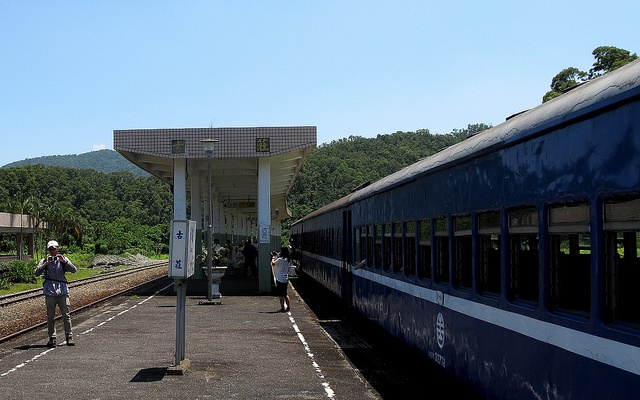Describe the objects in this image and their specific colors. I can see train in lightblue, black, navy, gray, and darkgray tones, people in lightblue, black, gray, navy, and darkgray tones, people in lightblue, black, gray, and darkblue tones, people in lightblue and black tones, and people in lightblue, black, darkgreen, and gray tones in this image. 